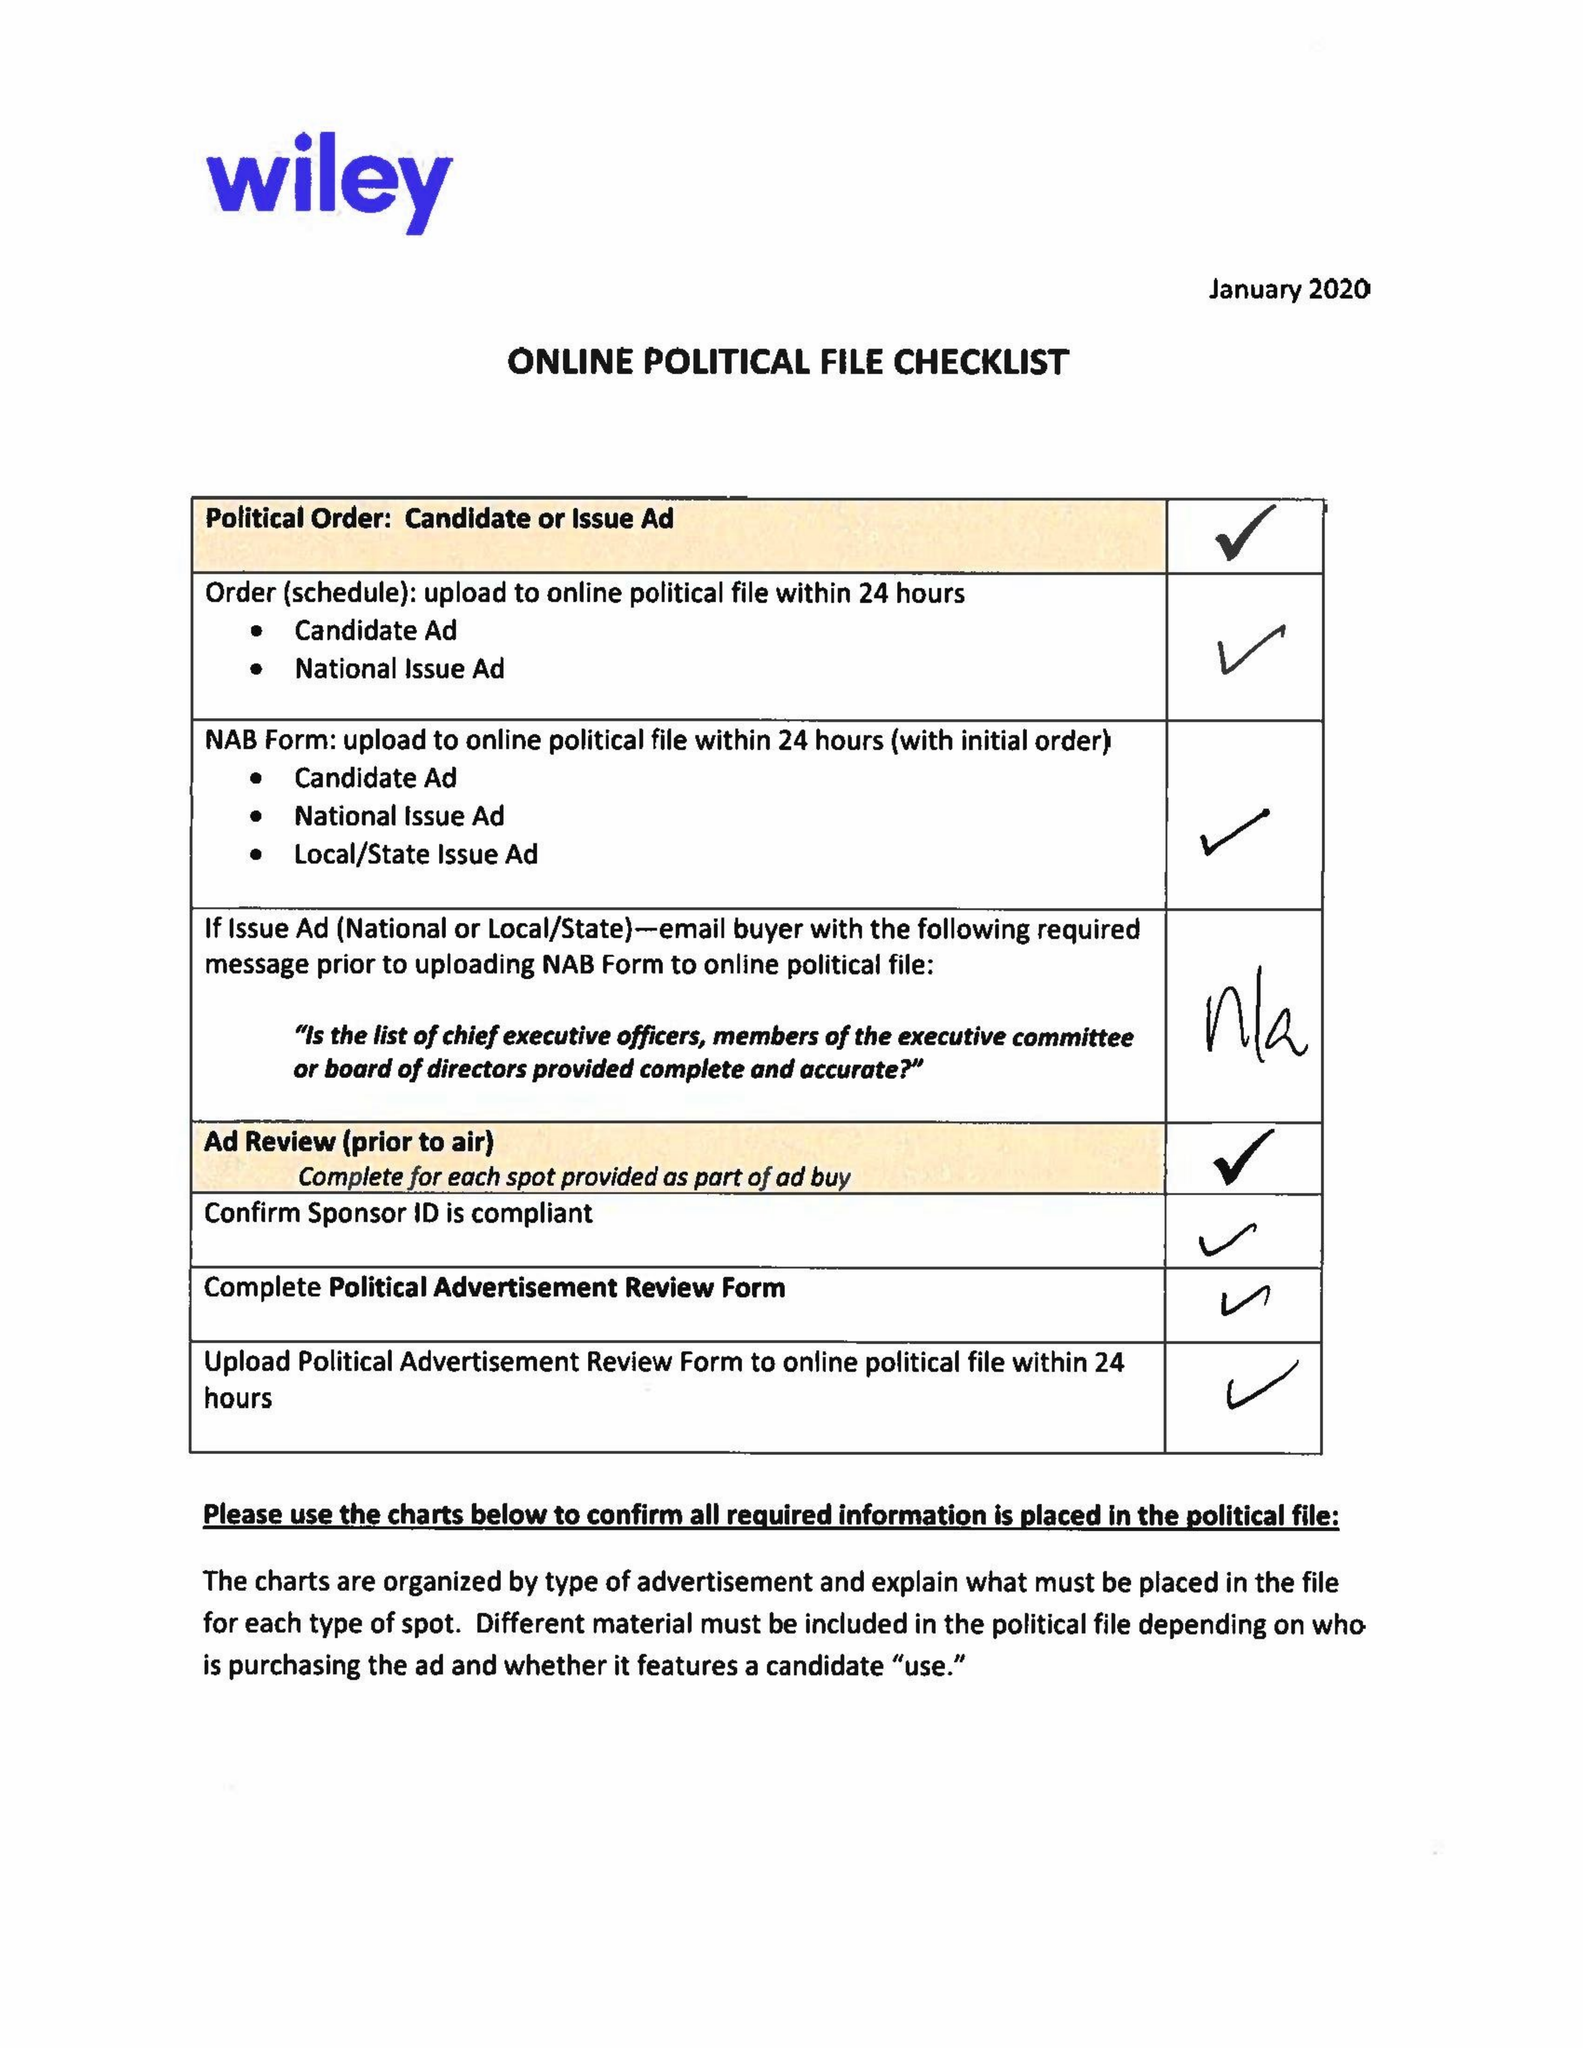What is the value for the advertiser?
Answer the question using a single word or phrase. COMMITTEE TO RE-ELECT MARY WINDOM, 